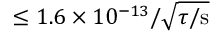<formula> <loc_0><loc_0><loc_500><loc_500>\leq 1 . 6 \times 1 0 ^ { - 1 3 } / \sqrt { \tau / s }</formula> 